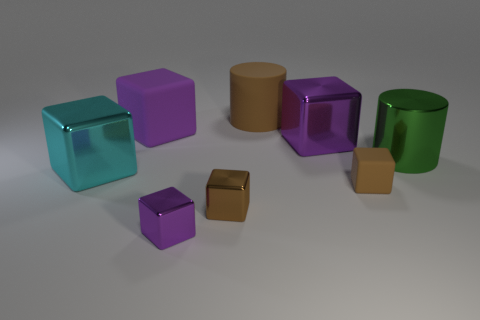There is a metal block that is the same color as the tiny matte object; what is its size?
Your response must be concise. Small. There is another block that is the same color as the small rubber cube; what is its material?
Provide a succinct answer. Metal. What is the shape of the brown thing left of the brown matte cylinder?
Provide a succinct answer. Cube. Are there any small rubber cubes that have the same color as the large rubber cylinder?
Keep it short and to the point. Yes. There is a rubber cube that is on the left side of the big brown rubber object; is it the same size as the matte object to the right of the brown cylinder?
Ensure brevity in your answer.  No. Is the number of small purple shiny objects that are behind the purple matte cube greater than the number of small things that are in front of the brown metal block?
Your response must be concise. No. Are there any tiny purple blocks made of the same material as the small purple object?
Your answer should be compact. No. Is the small matte block the same color as the shiny cylinder?
Your answer should be compact. No. What is the purple thing that is both in front of the big purple rubber cube and left of the large purple shiny object made of?
Your response must be concise. Metal. The small rubber thing has what color?
Ensure brevity in your answer.  Brown. 